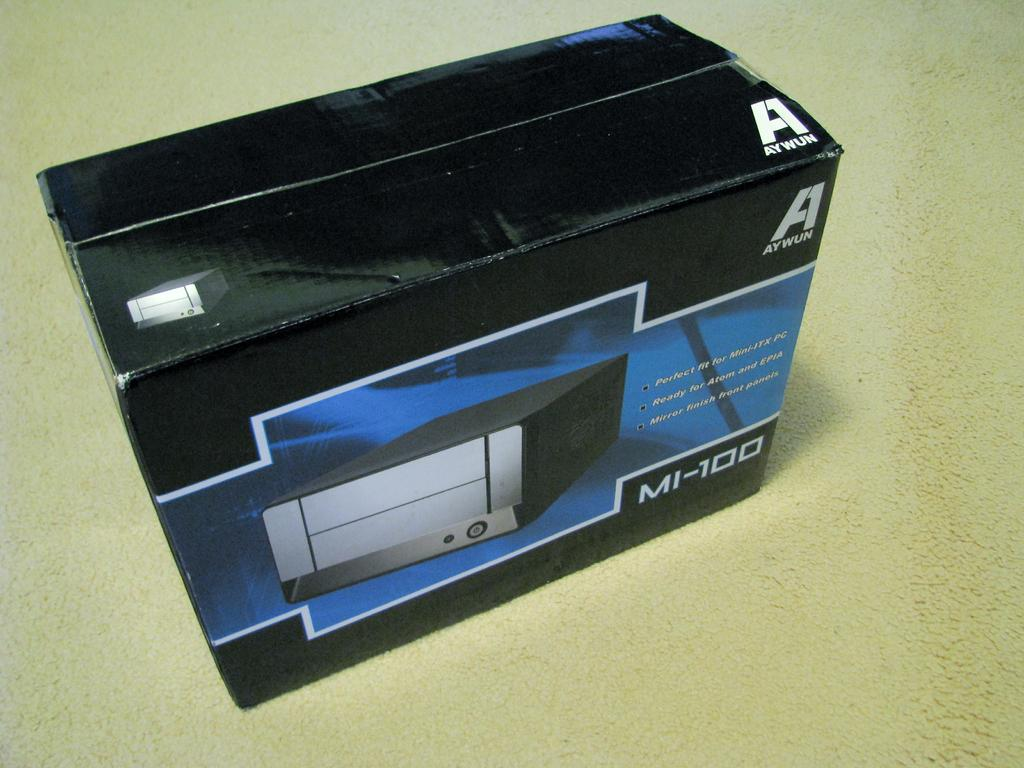<image>
Write a terse but informative summary of the picture. an MI-100 computer component is in a balck box 